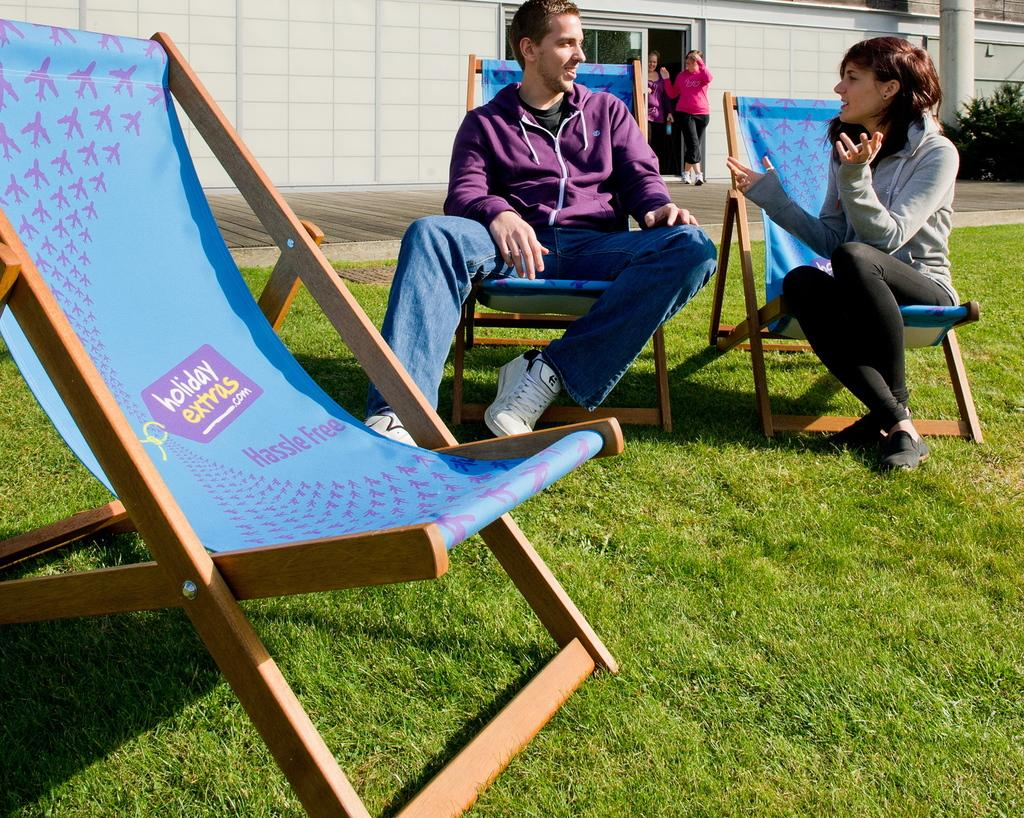How many chairs are in the image? There are three chairs in the image. Who is sitting on the chairs? Two people are seated on the chairs. Where are the chairs located? The chairs are on the grass. What can be seen in the background of the image? There are two people walking, buildings, and plants visible in the background. What type of wool is the sheep shedding in the image? There is no sheep or wool present in the image. What action are the people walking in the background performing? The people walking in the background are simply walking, and no specific action is being performed. 